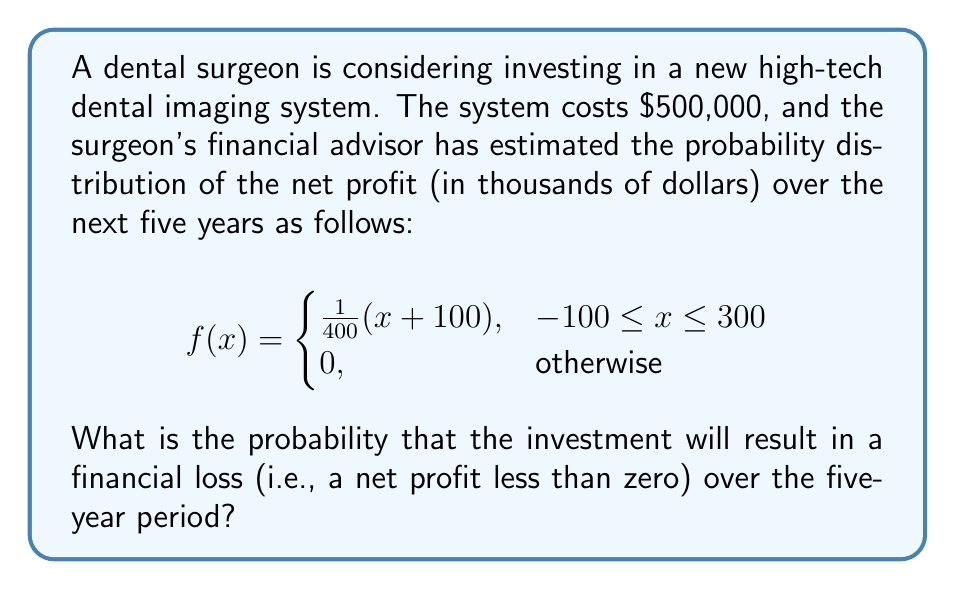What is the answer to this math problem? To solve this problem, we need to find the probability that the net profit is less than zero. This can be done by integrating the probability density function from -100 (the lower bound of the distribution) to 0.

The probability of a loss is given by:

$$P(X < 0) = \int_{-100}^{0} f(x) dx$$

Substituting the given function:

$$P(X < 0) = \int_{-100}^{0} \frac{1}{400}(x+100) dx$$

To integrate this, we can use the power rule:

$$P(X < 0) = \frac{1}{400} \left[\frac{1}{2}x^2 + 100x\right]_{-100}^{0}$$

Evaluating the integral:

$$P(X < 0) = \frac{1}{400} \left[(0 + 0) - (\frac{1}{2}(-100)^2 + 100(-100))\right]$$

$$P(X < 0) = \frac{1}{400} \left[0 - (5000 - 10000)\right]$$

$$P(X < 0) = \frac{1}{400} (5000)$$

$$P(X < 0) = \frac{25}{2} = 12.5$$

Therefore, the probability of a financial loss is 0.125 or 12.5%.
Answer: The probability that the investment will result in a financial loss over the five-year period is 0.125 or 12.5%. 